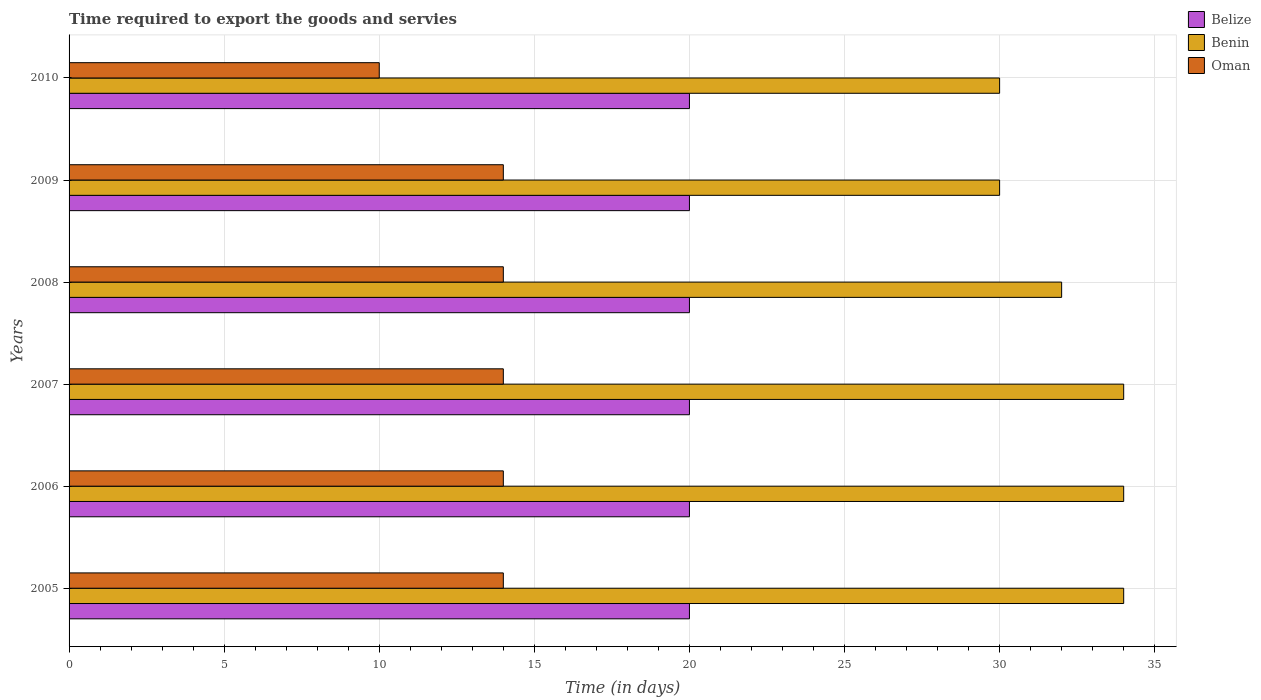How many different coloured bars are there?
Offer a terse response. 3. How many groups of bars are there?
Keep it short and to the point. 6. Are the number of bars on each tick of the Y-axis equal?
Give a very brief answer. Yes. What is the label of the 1st group of bars from the top?
Your answer should be compact. 2010. What is the number of days required to export the goods and services in Benin in 2007?
Offer a very short reply. 34. Across all years, what is the maximum number of days required to export the goods and services in Benin?
Offer a terse response. 34. Across all years, what is the minimum number of days required to export the goods and services in Belize?
Give a very brief answer. 20. What is the total number of days required to export the goods and services in Benin in the graph?
Offer a very short reply. 194. What is the difference between the number of days required to export the goods and services in Belize in 2005 and that in 2007?
Offer a terse response. 0. What is the difference between the number of days required to export the goods and services in Oman in 2006 and the number of days required to export the goods and services in Benin in 2009?
Provide a short and direct response. -16. In the year 2009, what is the difference between the number of days required to export the goods and services in Belize and number of days required to export the goods and services in Oman?
Keep it short and to the point. 6. What is the ratio of the number of days required to export the goods and services in Belize in 2008 to that in 2010?
Provide a short and direct response. 1. Is the difference between the number of days required to export the goods and services in Belize in 2005 and 2007 greater than the difference between the number of days required to export the goods and services in Oman in 2005 and 2007?
Give a very brief answer. No. In how many years, is the number of days required to export the goods and services in Benin greater than the average number of days required to export the goods and services in Benin taken over all years?
Your answer should be compact. 3. What does the 3rd bar from the top in 2005 represents?
Make the answer very short. Belize. What does the 1st bar from the bottom in 2008 represents?
Give a very brief answer. Belize. Is it the case that in every year, the sum of the number of days required to export the goods and services in Oman and number of days required to export the goods and services in Benin is greater than the number of days required to export the goods and services in Belize?
Make the answer very short. Yes. Are all the bars in the graph horizontal?
Provide a succinct answer. Yes. Are the values on the major ticks of X-axis written in scientific E-notation?
Your answer should be very brief. No. Does the graph contain grids?
Your answer should be very brief. Yes. Where does the legend appear in the graph?
Give a very brief answer. Top right. What is the title of the graph?
Your answer should be very brief. Time required to export the goods and servies. Does "Latin America(all income levels)" appear as one of the legend labels in the graph?
Your answer should be very brief. No. What is the label or title of the X-axis?
Offer a very short reply. Time (in days). What is the Time (in days) in Benin in 2005?
Your answer should be compact. 34. What is the Time (in days) in Oman in 2005?
Ensure brevity in your answer.  14. What is the Time (in days) in Benin in 2006?
Keep it short and to the point. 34. What is the Time (in days) of Oman in 2006?
Keep it short and to the point. 14. What is the Time (in days) in Belize in 2007?
Your response must be concise. 20. What is the Time (in days) in Oman in 2007?
Provide a succinct answer. 14. What is the Time (in days) in Benin in 2009?
Provide a short and direct response. 30. What is the Time (in days) in Oman in 2009?
Make the answer very short. 14. Across all years, what is the minimum Time (in days) in Belize?
Offer a very short reply. 20. Across all years, what is the minimum Time (in days) of Benin?
Your response must be concise. 30. Across all years, what is the minimum Time (in days) of Oman?
Provide a succinct answer. 10. What is the total Time (in days) in Belize in the graph?
Give a very brief answer. 120. What is the total Time (in days) in Benin in the graph?
Offer a very short reply. 194. What is the difference between the Time (in days) of Belize in 2005 and that in 2006?
Your response must be concise. 0. What is the difference between the Time (in days) of Benin in 2005 and that in 2006?
Your answer should be very brief. 0. What is the difference between the Time (in days) of Oman in 2005 and that in 2006?
Your answer should be compact. 0. What is the difference between the Time (in days) of Oman in 2005 and that in 2007?
Make the answer very short. 0. What is the difference between the Time (in days) in Belize in 2005 and that in 2008?
Your response must be concise. 0. What is the difference between the Time (in days) of Benin in 2005 and that in 2008?
Give a very brief answer. 2. What is the difference between the Time (in days) in Benin in 2005 and that in 2009?
Offer a very short reply. 4. What is the difference between the Time (in days) in Belize in 2005 and that in 2010?
Ensure brevity in your answer.  0. What is the difference between the Time (in days) in Benin in 2005 and that in 2010?
Offer a terse response. 4. What is the difference between the Time (in days) of Benin in 2006 and that in 2008?
Provide a short and direct response. 2. What is the difference between the Time (in days) in Oman in 2006 and that in 2008?
Your answer should be very brief. 0. What is the difference between the Time (in days) of Oman in 2006 and that in 2009?
Offer a very short reply. 0. What is the difference between the Time (in days) in Belize in 2006 and that in 2010?
Ensure brevity in your answer.  0. What is the difference between the Time (in days) in Belize in 2007 and that in 2008?
Your response must be concise. 0. What is the difference between the Time (in days) in Benin in 2007 and that in 2009?
Make the answer very short. 4. What is the difference between the Time (in days) of Belize in 2007 and that in 2010?
Give a very brief answer. 0. What is the difference between the Time (in days) in Oman in 2007 and that in 2010?
Offer a very short reply. 4. What is the difference between the Time (in days) in Belize in 2008 and that in 2009?
Keep it short and to the point. 0. What is the difference between the Time (in days) in Benin in 2008 and that in 2009?
Keep it short and to the point. 2. What is the difference between the Time (in days) of Oman in 2008 and that in 2009?
Provide a short and direct response. 0. What is the difference between the Time (in days) in Belize in 2009 and that in 2010?
Make the answer very short. 0. What is the difference between the Time (in days) of Oman in 2009 and that in 2010?
Your response must be concise. 4. What is the difference between the Time (in days) in Belize in 2005 and the Time (in days) in Benin in 2007?
Keep it short and to the point. -14. What is the difference between the Time (in days) of Belize in 2005 and the Time (in days) of Oman in 2008?
Provide a succinct answer. 6. What is the difference between the Time (in days) in Benin in 2005 and the Time (in days) in Oman in 2008?
Your response must be concise. 20. What is the difference between the Time (in days) of Belize in 2005 and the Time (in days) of Benin in 2009?
Ensure brevity in your answer.  -10. What is the difference between the Time (in days) of Benin in 2005 and the Time (in days) of Oman in 2010?
Offer a very short reply. 24. What is the difference between the Time (in days) of Belize in 2006 and the Time (in days) of Benin in 2008?
Provide a short and direct response. -12. What is the difference between the Time (in days) of Belize in 2006 and the Time (in days) of Oman in 2008?
Give a very brief answer. 6. What is the difference between the Time (in days) of Benin in 2006 and the Time (in days) of Oman in 2008?
Keep it short and to the point. 20. What is the difference between the Time (in days) of Belize in 2006 and the Time (in days) of Benin in 2009?
Ensure brevity in your answer.  -10. What is the difference between the Time (in days) in Belize in 2006 and the Time (in days) in Oman in 2009?
Keep it short and to the point. 6. What is the difference between the Time (in days) in Benin in 2006 and the Time (in days) in Oman in 2010?
Make the answer very short. 24. What is the difference between the Time (in days) of Benin in 2007 and the Time (in days) of Oman in 2008?
Offer a very short reply. 20. What is the difference between the Time (in days) of Belize in 2007 and the Time (in days) of Oman in 2009?
Your response must be concise. 6. What is the difference between the Time (in days) in Benin in 2007 and the Time (in days) in Oman in 2009?
Ensure brevity in your answer.  20. What is the difference between the Time (in days) of Belize in 2007 and the Time (in days) of Benin in 2010?
Your answer should be very brief. -10. What is the difference between the Time (in days) of Belize in 2008 and the Time (in days) of Benin in 2009?
Your response must be concise. -10. What is the difference between the Time (in days) of Benin in 2008 and the Time (in days) of Oman in 2009?
Provide a short and direct response. 18. What is the difference between the Time (in days) in Belize in 2008 and the Time (in days) in Benin in 2010?
Provide a short and direct response. -10. What is the difference between the Time (in days) in Belize in 2008 and the Time (in days) in Oman in 2010?
Your answer should be compact. 10. What is the difference between the Time (in days) of Benin in 2008 and the Time (in days) of Oman in 2010?
Make the answer very short. 22. What is the difference between the Time (in days) of Belize in 2009 and the Time (in days) of Benin in 2010?
Give a very brief answer. -10. What is the average Time (in days) of Benin per year?
Offer a terse response. 32.33. What is the average Time (in days) of Oman per year?
Make the answer very short. 13.33. In the year 2005, what is the difference between the Time (in days) in Benin and Time (in days) in Oman?
Give a very brief answer. 20. In the year 2006, what is the difference between the Time (in days) of Belize and Time (in days) of Oman?
Your answer should be very brief. 6. In the year 2008, what is the difference between the Time (in days) of Benin and Time (in days) of Oman?
Make the answer very short. 18. In the year 2009, what is the difference between the Time (in days) in Belize and Time (in days) in Benin?
Ensure brevity in your answer.  -10. In the year 2009, what is the difference between the Time (in days) in Belize and Time (in days) in Oman?
Offer a very short reply. 6. In the year 2010, what is the difference between the Time (in days) of Belize and Time (in days) of Oman?
Your answer should be compact. 10. In the year 2010, what is the difference between the Time (in days) in Benin and Time (in days) in Oman?
Ensure brevity in your answer.  20. What is the ratio of the Time (in days) of Oman in 2005 to that in 2006?
Provide a short and direct response. 1. What is the ratio of the Time (in days) in Belize in 2005 to that in 2007?
Your answer should be very brief. 1. What is the ratio of the Time (in days) of Benin in 2005 to that in 2007?
Your answer should be very brief. 1. What is the ratio of the Time (in days) in Belize in 2005 to that in 2008?
Your response must be concise. 1. What is the ratio of the Time (in days) in Oman in 2005 to that in 2008?
Offer a very short reply. 1. What is the ratio of the Time (in days) of Benin in 2005 to that in 2009?
Ensure brevity in your answer.  1.13. What is the ratio of the Time (in days) of Benin in 2005 to that in 2010?
Give a very brief answer. 1.13. What is the ratio of the Time (in days) of Belize in 2006 to that in 2008?
Your answer should be compact. 1. What is the ratio of the Time (in days) of Benin in 2006 to that in 2008?
Offer a terse response. 1.06. What is the ratio of the Time (in days) in Oman in 2006 to that in 2008?
Offer a very short reply. 1. What is the ratio of the Time (in days) in Belize in 2006 to that in 2009?
Offer a terse response. 1. What is the ratio of the Time (in days) of Benin in 2006 to that in 2009?
Keep it short and to the point. 1.13. What is the ratio of the Time (in days) of Belize in 2006 to that in 2010?
Your answer should be very brief. 1. What is the ratio of the Time (in days) of Benin in 2006 to that in 2010?
Keep it short and to the point. 1.13. What is the ratio of the Time (in days) in Belize in 2007 to that in 2008?
Your answer should be very brief. 1. What is the ratio of the Time (in days) in Oman in 2007 to that in 2008?
Offer a terse response. 1. What is the ratio of the Time (in days) in Belize in 2007 to that in 2009?
Give a very brief answer. 1. What is the ratio of the Time (in days) in Benin in 2007 to that in 2009?
Make the answer very short. 1.13. What is the ratio of the Time (in days) in Oman in 2007 to that in 2009?
Your answer should be compact. 1. What is the ratio of the Time (in days) of Belize in 2007 to that in 2010?
Offer a terse response. 1. What is the ratio of the Time (in days) in Benin in 2007 to that in 2010?
Provide a short and direct response. 1.13. What is the ratio of the Time (in days) in Benin in 2008 to that in 2009?
Provide a succinct answer. 1.07. What is the ratio of the Time (in days) of Oman in 2008 to that in 2009?
Give a very brief answer. 1. What is the ratio of the Time (in days) of Benin in 2008 to that in 2010?
Make the answer very short. 1.07. What is the ratio of the Time (in days) of Benin in 2009 to that in 2010?
Provide a succinct answer. 1. What is the ratio of the Time (in days) in Oman in 2009 to that in 2010?
Keep it short and to the point. 1.4. What is the difference between the highest and the second highest Time (in days) of Belize?
Your answer should be compact. 0. What is the difference between the highest and the second highest Time (in days) in Oman?
Make the answer very short. 0. What is the difference between the highest and the lowest Time (in days) in Oman?
Give a very brief answer. 4. 